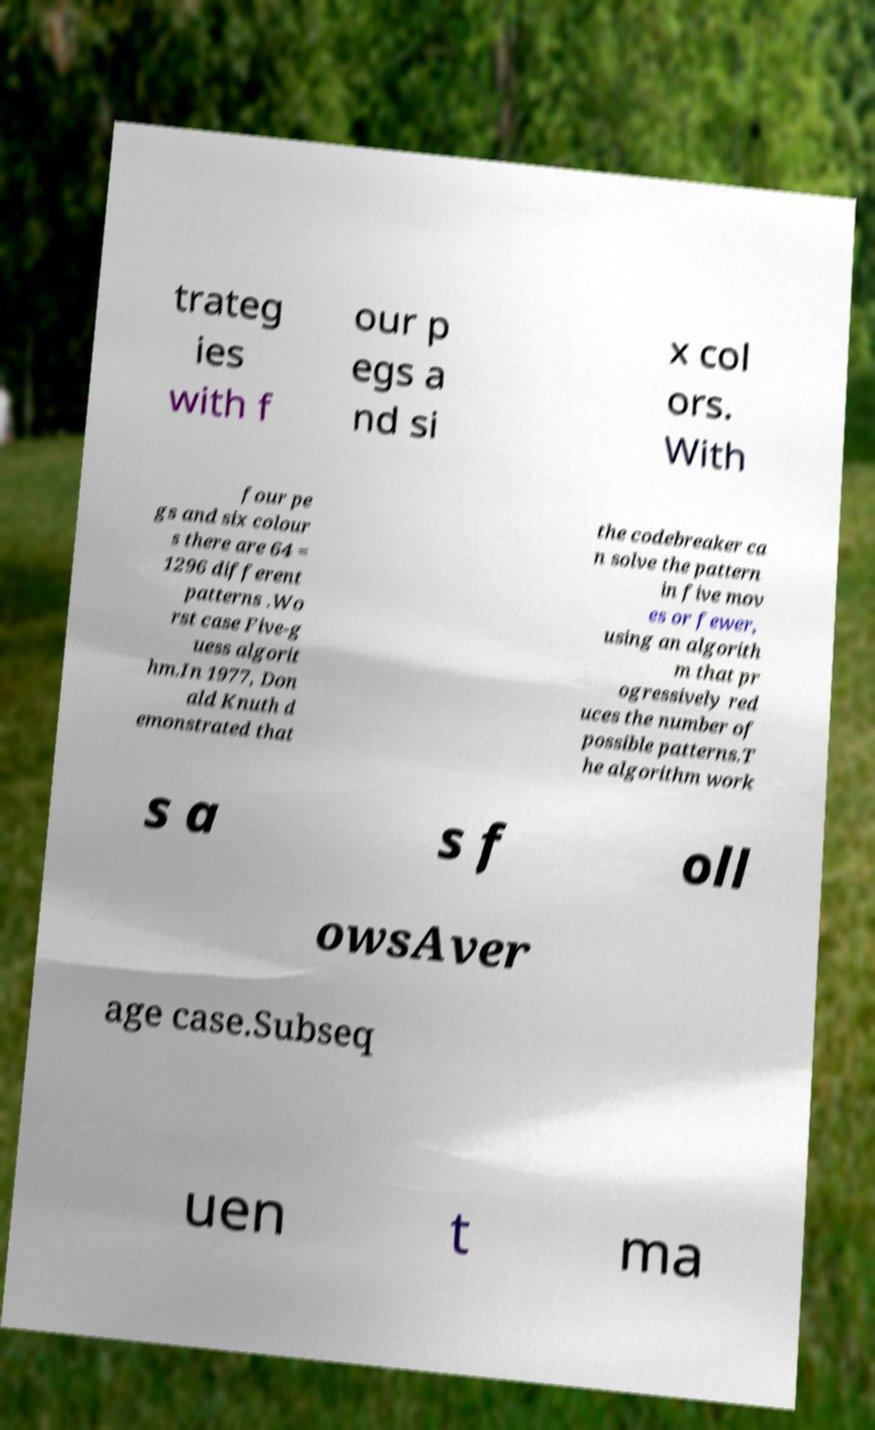I need the written content from this picture converted into text. Can you do that? trateg ies with f our p egs a nd si x col ors. With four pe gs and six colour s there are 64 = 1296 different patterns .Wo rst case Five-g uess algorit hm.In 1977, Don ald Knuth d emonstrated that the codebreaker ca n solve the pattern in five mov es or fewer, using an algorith m that pr ogressively red uces the number of possible patterns.T he algorithm work s a s f oll owsAver age case.Subseq uen t ma 